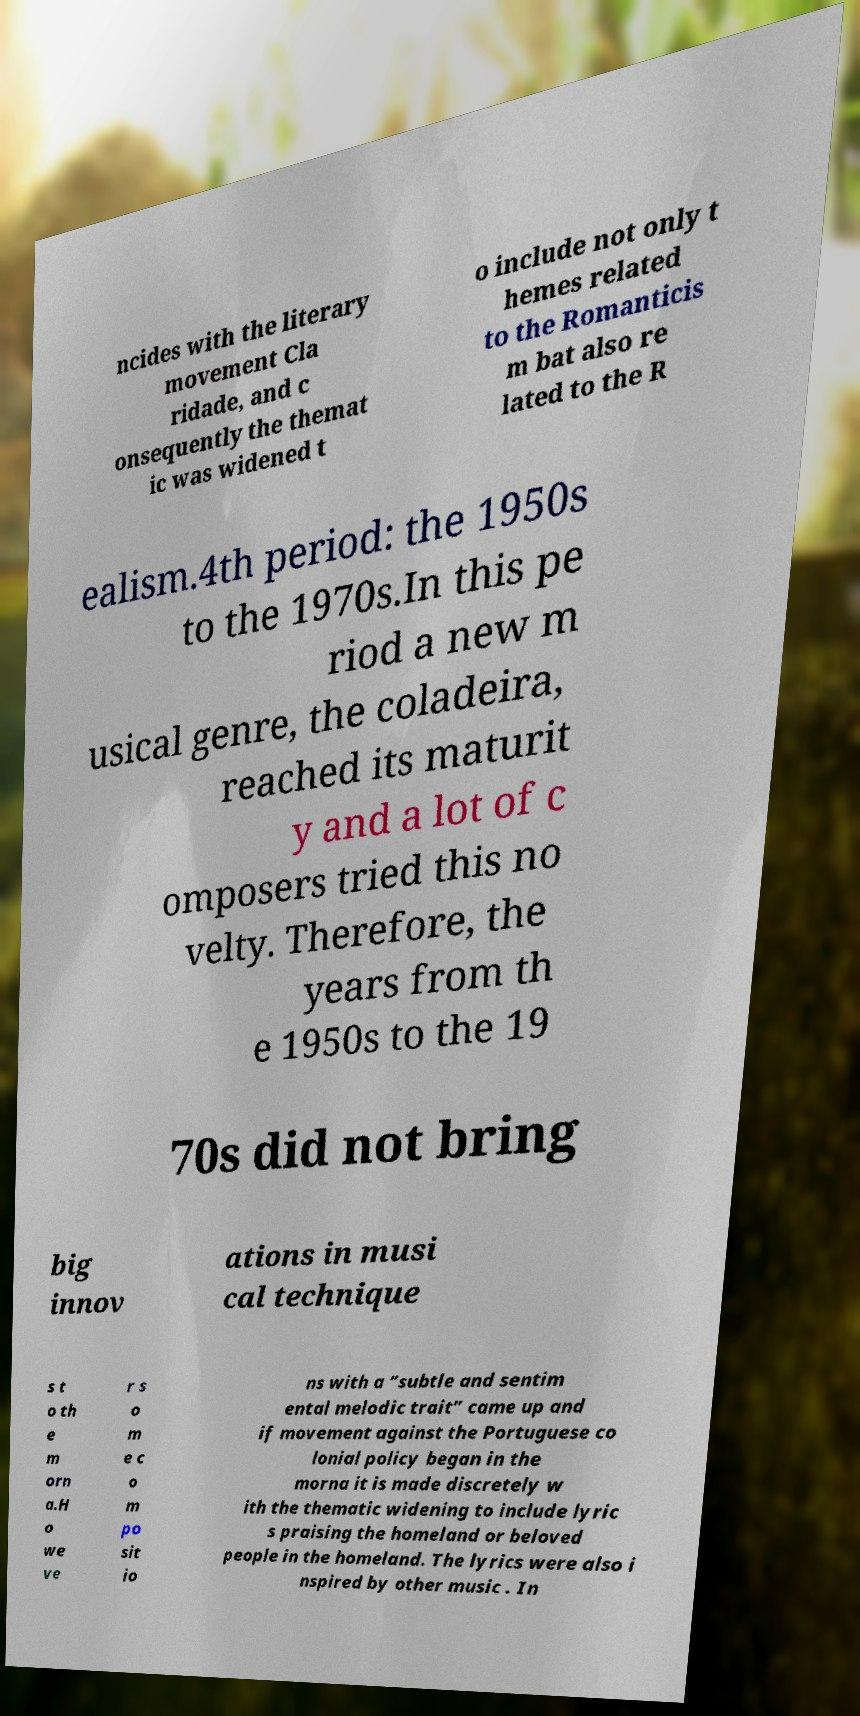Can you accurately transcribe the text from the provided image for me? ncides with the literary movement Cla ridade, and c onsequently the themat ic was widened t o include not only t hemes related to the Romanticis m bat also re lated to the R ealism.4th period: the 1950s to the 1970s.In this pe riod a new m usical genre, the coladeira, reached its maturit y and a lot of c omposers tried this no velty. Therefore, the years from th e 1950s to the 19 70s did not bring big innov ations in musi cal technique s t o th e m orn a.H o we ve r s o m e c o m po sit io ns with a “subtle and sentim ental melodic trait” came up and if movement against the Portuguese co lonial policy began in the morna it is made discretely w ith the thematic widening to include lyric s praising the homeland or beloved people in the homeland. The lyrics were also i nspired by other music . In 